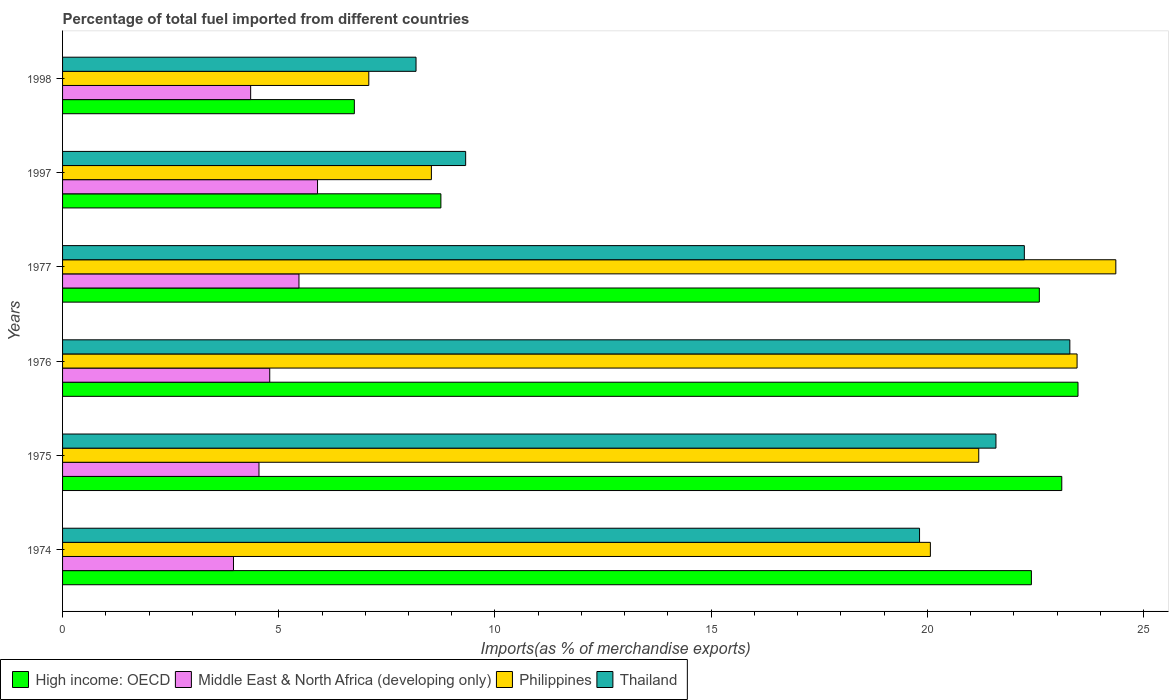How many groups of bars are there?
Give a very brief answer. 6. Are the number of bars on each tick of the Y-axis equal?
Give a very brief answer. Yes. In how many cases, is the number of bars for a given year not equal to the number of legend labels?
Keep it short and to the point. 0. What is the percentage of imports to different countries in Thailand in 1976?
Provide a succinct answer. 23.3. Across all years, what is the maximum percentage of imports to different countries in Middle East & North Africa (developing only)?
Ensure brevity in your answer.  5.9. Across all years, what is the minimum percentage of imports to different countries in High income: OECD?
Your answer should be compact. 6.75. In which year was the percentage of imports to different countries in Thailand maximum?
Make the answer very short. 1976. What is the total percentage of imports to different countries in High income: OECD in the graph?
Provide a succinct answer. 107.09. What is the difference between the percentage of imports to different countries in Middle East & North Africa (developing only) in 1975 and that in 1998?
Keep it short and to the point. 0.19. What is the difference between the percentage of imports to different countries in High income: OECD in 1977 and the percentage of imports to different countries in Philippines in 1974?
Your response must be concise. 2.52. What is the average percentage of imports to different countries in High income: OECD per year?
Provide a succinct answer. 17.85. In the year 1977, what is the difference between the percentage of imports to different countries in Middle East & North Africa (developing only) and percentage of imports to different countries in Thailand?
Provide a succinct answer. -16.78. What is the ratio of the percentage of imports to different countries in Middle East & North Africa (developing only) in 1975 to that in 1998?
Your answer should be compact. 1.04. Is the difference between the percentage of imports to different countries in Middle East & North Africa (developing only) in 1977 and 1997 greater than the difference between the percentage of imports to different countries in Thailand in 1977 and 1997?
Provide a succinct answer. No. What is the difference between the highest and the second highest percentage of imports to different countries in Middle East & North Africa (developing only)?
Offer a very short reply. 0.43. What is the difference between the highest and the lowest percentage of imports to different countries in High income: OECD?
Provide a succinct answer. 16.74. Is the sum of the percentage of imports to different countries in High income: OECD in 1976 and 1977 greater than the maximum percentage of imports to different countries in Thailand across all years?
Keep it short and to the point. Yes. What does the 4th bar from the top in 1975 represents?
Keep it short and to the point. High income: OECD. What does the 4th bar from the bottom in 1998 represents?
Offer a very short reply. Thailand. How many bars are there?
Provide a succinct answer. 24. Are all the bars in the graph horizontal?
Make the answer very short. Yes. How many years are there in the graph?
Your response must be concise. 6. Are the values on the major ticks of X-axis written in scientific E-notation?
Provide a succinct answer. No. Does the graph contain grids?
Offer a terse response. No. How many legend labels are there?
Provide a succinct answer. 4. What is the title of the graph?
Ensure brevity in your answer.  Percentage of total fuel imported from different countries. What is the label or title of the X-axis?
Provide a short and direct response. Imports(as % of merchandise exports). What is the Imports(as % of merchandise exports) of High income: OECD in 1974?
Keep it short and to the point. 22.41. What is the Imports(as % of merchandise exports) in Middle East & North Africa (developing only) in 1974?
Your response must be concise. 3.95. What is the Imports(as % of merchandise exports) in Philippines in 1974?
Offer a very short reply. 20.07. What is the Imports(as % of merchandise exports) of Thailand in 1974?
Your response must be concise. 19.82. What is the Imports(as % of merchandise exports) of High income: OECD in 1975?
Offer a terse response. 23.11. What is the Imports(as % of merchandise exports) in Middle East & North Africa (developing only) in 1975?
Offer a very short reply. 4.54. What is the Imports(as % of merchandise exports) in Philippines in 1975?
Keep it short and to the point. 21.19. What is the Imports(as % of merchandise exports) in Thailand in 1975?
Your answer should be compact. 21.59. What is the Imports(as % of merchandise exports) of High income: OECD in 1976?
Offer a very short reply. 23.48. What is the Imports(as % of merchandise exports) in Middle East & North Africa (developing only) in 1976?
Offer a very short reply. 4.79. What is the Imports(as % of merchandise exports) of Philippines in 1976?
Provide a short and direct response. 23.46. What is the Imports(as % of merchandise exports) of Thailand in 1976?
Ensure brevity in your answer.  23.3. What is the Imports(as % of merchandise exports) of High income: OECD in 1977?
Provide a succinct answer. 22.59. What is the Imports(as % of merchandise exports) of Middle East & North Africa (developing only) in 1977?
Make the answer very short. 5.47. What is the Imports(as % of merchandise exports) in Philippines in 1977?
Your answer should be very brief. 24.36. What is the Imports(as % of merchandise exports) of Thailand in 1977?
Your response must be concise. 22.24. What is the Imports(as % of merchandise exports) in High income: OECD in 1997?
Keep it short and to the point. 8.75. What is the Imports(as % of merchandise exports) of Middle East & North Africa (developing only) in 1997?
Give a very brief answer. 5.9. What is the Imports(as % of merchandise exports) of Philippines in 1997?
Your answer should be compact. 8.53. What is the Imports(as % of merchandise exports) of Thailand in 1997?
Provide a succinct answer. 9.32. What is the Imports(as % of merchandise exports) in High income: OECD in 1998?
Keep it short and to the point. 6.75. What is the Imports(as % of merchandise exports) in Middle East & North Africa (developing only) in 1998?
Make the answer very short. 4.35. What is the Imports(as % of merchandise exports) in Philippines in 1998?
Give a very brief answer. 7.08. What is the Imports(as % of merchandise exports) of Thailand in 1998?
Offer a very short reply. 8.17. Across all years, what is the maximum Imports(as % of merchandise exports) of High income: OECD?
Your answer should be compact. 23.48. Across all years, what is the maximum Imports(as % of merchandise exports) in Middle East & North Africa (developing only)?
Make the answer very short. 5.9. Across all years, what is the maximum Imports(as % of merchandise exports) of Philippines?
Provide a succinct answer. 24.36. Across all years, what is the maximum Imports(as % of merchandise exports) in Thailand?
Ensure brevity in your answer.  23.3. Across all years, what is the minimum Imports(as % of merchandise exports) in High income: OECD?
Give a very brief answer. 6.75. Across all years, what is the minimum Imports(as % of merchandise exports) of Middle East & North Africa (developing only)?
Offer a very short reply. 3.95. Across all years, what is the minimum Imports(as % of merchandise exports) in Philippines?
Your answer should be compact. 7.08. Across all years, what is the minimum Imports(as % of merchandise exports) in Thailand?
Make the answer very short. 8.17. What is the total Imports(as % of merchandise exports) in High income: OECD in the graph?
Your answer should be very brief. 107.09. What is the total Imports(as % of merchandise exports) of Middle East & North Africa (developing only) in the graph?
Keep it short and to the point. 29. What is the total Imports(as % of merchandise exports) in Philippines in the graph?
Offer a terse response. 104.69. What is the total Imports(as % of merchandise exports) of Thailand in the graph?
Provide a short and direct response. 104.44. What is the difference between the Imports(as % of merchandise exports) in High income: OECD in 1974 and that in 1975?
Your answer should be compact. -0.7. What is the difference between the Imports(as % of merchandise exports) in Middle East & North Africa (developing only) in 1974 and that in 1975?
Ensure brevity in your answer.  -0.59. What is the difference between the Imports(as % of merchandise exports) of Philippines in 1974 and that in 1975?
Offer a terse response. -1.12. What is the difference between the Imports(as % of merchandise exports) of Thailand in 1974 and that in 1975?
Make the answer very short. -1.77. What is the difference between the Imports(as % of merchandise exports) of High income: OECD in 1974 and that in 1976?
Your answer should be compact. -1.08. What is the difference between the Imports(as % of merchandise exports) in Middle East & North Africa (developing only) in 1974 and that in 1976?
Your answer should be very brief. -0.84. What is the difference between the Imports(as % of merchandise exports) of Philippines in 1974 and that in 1976?
Give a very brief answer. -3.39. What is the difference between the Imports(as % of merchandise exports) in Thailand in 1974 and that in 1976?
Offer a terse response. -3.48. What is the difference between the Imports(as % of merchandise exports) of High income: OECD in 1974 and that in 1977?
Your response must be concise. -0.18. What is the difference between the Imports(as % of merchandise exports) in Middle East & North Africa (developing only) in 1974 and that in 1977?
Your answer should be compact. -1.51. What is the difference between the Imports(as % of merchandise exports) in Philippines in 1974 and that in 1977?
Offer a very short reply. -4.29. What is the difference between the Imports(as % of merchandise exports) of Thailand in 1974 and that in 1977?
Offer a very short reply. -2.42. What is the difference between the Imports(as % of merchandise exports) of High income: OECD in 1974 and that in 1997?
Your answer should be compact. 13.66. What is the difference between the Imports(as % of merchandise exports) in Middle East & North Africa (developing only) in 1974 and that in 1997?
Your response must be concise. -1.94. What is the difference between the Imports(as % of merchandise exports) in Philippines in 1974 and that in 1997?
Provide a succinct answer. 11.54. What is the difference between the Imports(as % of merchandise exports) in Thailand in 1974 and that in 1997?
Provide a short and direct response. 10.5. What is the difference between the Imports(as % of merchandise exports) in High income: OECD in 1974 and that in 1998?
Keep it short and to the point. 15.66. What is the difference between the Imports(as % of merchandise exports) in Middle East & North Africa (developing only) in 1974 and that in 1998?
Give a very brief answer. -0.4. What is the difference between the Imports(as % of merchandise exports) in Philippines in 1974 and that in 1998?
Give a very brief answer. 12.99. What is the difference between the Imports(as % of merchandise exports) in Thailand in 1974 and that in 1998?
Keep it short and to the point. 11.64. What is the difference between the Imports(as % of merchandise exports) in High income: OECD in 1975 and that in 1976?
Provide a short and direct response. -0.38. What is the difference between the Imports(as % of merchandise exports) in Middle East & North Africa (developing only) in 1975 and that in 1976?
Offer a very short reply. -0.25. What is the difference between the Imports(as % of merchandise exports) in Philippines in 1975 and that in 1976?
Offer a terse response. -2.27. What is the difference between the Imports(as % of merchandise exports) in Thailand in 1975 and that in 1976?
Offer a very short reply. -1.71. What is the difference between the Imports(as % of merchandise exports) of High income: OECD in 1975 and that in 1977?
Your answer should be compact. 0.52. What is the difference between the Imports(as % of merchandise exports) in Middle East & North Africa (developing only) in 1975 and that in 1977?
Provide a succinct answer. -0.92. What is the difference between the Imports(as % of merchandise exports) in Philippines in 1975 and that in 1977?
Your answer should be very brief. -3.17. What is the difference between the Imports(as % of merchandise exports) in Thailand in 1975 and that in 1977?
Offer a terse response. -0.66. What is the difference between the Imports(as % of merchandise exports) in High income: OECD in 1975 and that in 1997?
Make the answer very short. 14.36. What is the difference between the Imports(as % of merchandise exports) of Middle East & North Africa (developing only) in 1975 and that in 1997?
Provide a succinct answer. -1.35. What is the difference between the Imports(as % of merchandise exports) in Philippines in 1975 and that in 1997?
Provide a succinct answer. 12.66. What is the difference between the Imports(as % of merchandise exports) in Thailand in 1975 and that in 1997?
Your answer should be compact. 12.26. What is the difference between the Imports(as % of merchandise exports) in High income: OECD in 1975 and that in 1998?
Make the answer very short. 16.36. What is the difference between the Imports(as % of merchandise exports) in Middle East & North Africa (developing only) in 1975 and that in 1998?
Offer a terse response. 0.19. What is the difference between the Imports(as % of merchandise exports) in Philippines in 1975 and that in 1998?
Offer a terse response. 14.11. What is the difference between the Imports(as % of merchandise exports) in Thailand in 1975 and that in 1998?
Offer a very short reply. 13.41. What is the difference between the Imports(as % of merchandise exports) in High income: OECD in 1976 and that in 1977?
Provide a short and direct response. 0.89. What is the difference between the Imports(as % of merchandise exports) of Middle East & North Africa (developing only) in 1976 and that in 1977?
Offer a terse response. -0.68. What is the difference between the Imports(as % of merchandise exports) of Philippines in 1976 and that in 1977?
Keep it short and to the point. -0.9. What is the difference between the Imports(as % of merchandise exports) of Thailand in 1976 and that in 1977?
Provide a short and direct response. 1.05. What is the difference between the Imports(as % of merchandise exports) of High income: OECD in 1976 and that in 1997?
Make the answer very short. 14.73. What is the difference between the Imports(as % of merchandise exports) in Middle East & North Africa (developing only) in 1976 and that in 1997?
Offer a terse response. -1.11. What is the difference between the Imports(as % of merchandise exports) in Philippines in 1976 and that in 1997?
Your answer should be very brief. 14.93. What is the difference between the Imports(as % of merchandise exports) in Thailand in 1976 and that in 1997?
Your response must be concise. 13.97. What is the difference between the Imports(as % of merchandise exports) of High income: OECD in 1976 and that in 1998?
Make the answer very short. 16.74. What is the difference between the Imports(as % of merchandise exports) of Middle East & North Africa (developing only) in 1976 and that in 1998?
Provide a short and direct response. 0.44. What is the difference between the Imports(as % of merchandise exports) in Philippines in 1976 and that in 1998?
Give a very brief answer. 16.38. What is the difference between the Imports(as % of merchandise exports) of Thailand in 1976 and that in 1998?
Offer a terse response. 15.12. What is the difference between the Imports(as % of merchandise exports) in High income: OECD in 1977 and that in 1997?
Keep it short and to the point. 13.84. What is the difference between the Imports(as % of merchandise exports) in Middle East & North Africa (developing only) in 1977 and that in 1997?
Provide a short and direct response. -0.43. What is the difference between the Imports(as % of merchandise exports) in Philippines in 1977 and that in 1997?
Provide a succinct answer. 15.83. What is the difference between the Imports(as % of merchandise exports) of Thailand in 1977 and that in 1997?
Ensure brevity in your answer.  12.92. What is the difference between the Imports(as % of merchandise exports) of High income: OECD in 1977 and that in 1998?
Give a very brief answer. 15.84. What is the difference between the Imports(as % of merchandise exports) of Middle East & North Africa (developing only) in 1977 and that in 1998?
Your response must be concise. 1.12. What is the difference between the Imports(as % of merchandise exports) in Philippines in 1977 and that in 1998?
Your answer should be very brief. 17.28. What is the difference between the Imports(as % of merchandise exports) in Thailand in 1977 and that in 1998?
Provide a short and direct response. 14.07. What is the difference between the Imports(as % of merchandise exports) of High income: OECD in 1997 and that in 1998?
Provide a succinct answer. 2. What is the difference between the Imports(as % of merchandise exports) in Middle East & North Africa (developing only) in 1997 and that in 1998?
Offer a very short reply. 1.55. What is the difference between the Imports(as % of merchandise exports) in Philippines in 1997 and that in 1998?
Make the answer very short. 1.45. What is the difference between the Imports(as % of merchandise exports) in Thailand in 1997 and that in 1998?
Offer a terse response. 1.15. What is the difference between the Imports(as % of merchandise exports) of High income: OECD in 1974 and the Imports(as % of merchandise exports) of Middle East & North Africa (developing only) in 1975?
Offer a terse response. 17.86. What is the difference between the Imports(as % of merchandise exports) of High income: OECD in 1974 and the Imports(as % of merchandise exports) of Philippines in 1975?
Give a very brief answer. 1.22. What is the difference between the Imports(as % of merchandise exports) of High income: OECD in 1974 and the Imports(as % of merchandise exports) of Thailand in 1975?
Offer a terse response. 0.82. What is the difference between the Imports(as % of merchandise exports) in Middle East & North Africa (developing only) in 1974 and the Imports(as % of merchandise exports) in Philippines in 1975?
Offer a very short reply. -17.24. What is the difference between the Imports(as % of merchandise exports) in Middle East & North Africa (developing only) in 1974 and the Imports(as % of merchandise exports) in Thailand in 1975?
Keep it short and to the point. -17.63. What is the difference between the Imports(as % of merchandise exports) in Philippines in 1974 and the Imports(as % of merchandise exports) in Thailand in 1975?
Provide a succinct answer. -1.52. What is the difference between the Imports(as % of merchandise exports) in High income: OECD in 1974 and the Imports(as % of merchandise exports) in Middle East & North Africa (developing only) in 1976?
Keep it short and to the point. 17.62. What is the difference between the Imports(as % of merchandise exports) in High income: OECD in 1974 and the Imports(as % of merchandise exports) in Philippines in 1976?
Offer a terse response. -1.06. What is the difference between the Imports(as % of merchandise exports) in High income: OECD in 1974 and the Imports(as % of merchandise exports) in Thailand in 1976?
Offer a very short reply. -0.89. What is the difference between the Imports(as % of merchandise exports) of Middle East & North Africa (developing only) in 1974 and the Imports(as % of merchandise exports) of Philippines in 1976?
Provide a short and direct response. -19.51. What is the difference between the Imports(as % of merchandise exports) of Middle East & North Africa (developing only) in 1974 and the Imports(as % of merchandise exports) of Thailand in 1976?
Make the answer very short. -19.34. What is the difference between the Imports(as % of merchandise exports) of Philippines in 1974 and the Imports(as % of merchandise exports) of Thailand in 1976?
Provide a succinct answer. -3.23. What is the difference between the Imports(as % of merchandise exports) in High income: OECD in 1974 and the Imports(as % of merchandise exports) in Middle East & North Africa (developing only) in 1977?
Provide a short and direct response. 16.94. What is the difference between the Imports(as % of merchandise exports) in High income: OECD in 1974 and the Imports(as % of merchandise exports) in Philippines in 1977?
Provide a succinct answer. -1.95. What is the difference between the Imports(as % of merchandise exports) of High income: OECD in 1974 and the Imports(as % of merchandise exports) of Thailand in 1977?
Your answer should be very brief. 0.16. What is the difference between the Imports(as % of merchandise exports) in Middle East & North Africa (developing only) in 1974 and the Imports(as % of merchandise exports) in Philippines in 1977?
Offer a very short reply. -20.41. What is the difference between the Imports(as % of merchandise exports) in Middle East & North Africa (developing only) in 1974 and the Imports(as % of merchandise exports) in Thailand in 1977?
Give a very brief answer. -18.29. What is the difference between the Imports(as % of merchandise exports) in Philippines in 1974 and the Imports(as % of merchandise exports) in Thailand in 1977?
Ensure brevity in your answer.  -2.17. What is the difference between the Imports(as % of merchandise exports) of High income: OECD in 1974 and the Imports(as % of merchandise exports) of Middle East & North Africa (developing only) in 1997?
Ensure brevity in your answer.  16.51. What is the difference between the Imports(as % of merchandise exports) of High income: OECD in 1974 and the Imports(as % of merchandise exports) of Philippines in 1997?
Provide a succinct answer. 13.88. What is the difference between the Imports(as % of merchandise exports) of High income: OECD in 1974 and the Imports(as % of merchandise exports) of Thailand in 1997?
Keep it short and to the point. 13.08. What is the difference between the Imports(as % of merchandise exports) of Middle East & North Africa (developing only) in 1974 and the Imports(as % of merchandise exports) of Philippines in 1997?
Offer a terse response. -4.58. What is the difference between the Imports(as % of merchandise exports) in Middle East & North Africa (developing only) in 1974 and the Imports(as % of merchandise exports) in Thailand in 1997?
Give a very brief answer. -5.37. What is the difference between the Imports(as % of merchandise exports) of Philippines in 1974 and the Imports(as % of merchandise exports) of Thailand in 1997?
Provide a short and direct response. 10.75. What is the difference between the Imports(as % of merchandise exports) of High income: OECD in 1974 and the Imports(as % of merchandise exports) of Middle East & North Africa (developing only) in 1998?
Offer a terse response. 18.06. What is the difference between the Imports(as % of merchandise exports) in High income: OECD in 1974 and the Imports(as % of merchandise exports) in Philippines in 1998?
Offer a very short reply. 15.32. What is the difference between the Imports(as % of merchandise exports) of High income: OECD in 1974 and the Imports(as % of merchandise exports) of Thailand in 1998?
Your answer should be compact. 14.23. What is the difference between the Imports(as % of merchandise exports) in Middle East & North Africa (developing only) in 1974 and the Imports(as % of merchandise exports) in Philippines in 1998?
Ensure brevity in your answer.  -3.13. What is the difference between the Imports(as % of merchandise exports) in Middle East & North Africa (developing only) in 1974 and the Imports(as % of merchandise exports) in Thailand in 1998?
Provide a short and direct response. -4.22. What is the difference between the Imports(as % of merchandise exports) of Philippines in 1974 and the Imports(as % of merchandise exports) of Thailand in 1998?
Ensure brevity in your answer.  11.9. What is the difference between the Imports(as % of merchandise exports) in High income: OECD in 1975 and the Imports(as % of merchandise exports) in Middle East & North Africa (developing only) in 1976?
Give a very brief answer. 18.32. What is the difference between the Imports(as % of merchandise exports) in High income: OECD in 1975 and the Imports(as % of merchandise exports) in Philippines in 1976?
Your answer should be compact. -0.35. What is the difference between the Imports(as % of merchandise exports) in High income: OECD in 1975 and the Imports(as % of merchandise exports) in Thailand in 1976?
Make the answer very short. -0.19. What is the difference between the Imports(as % of merchandise exports) in Middle East & North Africa (developing only) in 1975 and the Imports(as % of merchandise exports) in Philippines in 1976?
Your response must be concise. -18.92. What is the difference between the Imports(as % of merchandise exports) in Middle East & North Africa (developing only) in 1975 and the Imports(as % of merchandise exports) in Thailand in 1976?
Offer a terse response. -18.75. What is the difference between the Imports(as % of merchandise exports) in Philippines in 1975 and the Imports(as % of merchandise exports) in Thailand in 1976?
Your response must be concise. -2.11. What is the difference between the Imports(as % of merchandise exports) of High income: OECD in 1975 and the Imports(as % of merchandise exports) of Middle East & North Africa (developing only) in 1977?
Keep it short and to the point. 17.64. What is the difference between the Imports(as % of merchandise exports) of High income: OECD in 1975 and the Imports(as % of merchandise exports) of Philippines in 1977?
Keep it short and to the point. -1.25. What is the difference between the Imports(as % of merchandise exports) in High income: OECD in 1975 and the Imports(as % of merchandise exports) in Thailand in 1977?
Provide a succinct answer. 0.87. What is the difference between the Imports(as % of merchandise exports) of Middle East & North Africa (developing only) in 1975 and the Imports(as % of merchandise exports) of Philippines in 1977?
Provide a succinct answer. -19.82. What is the difference between the Imports(as % of merchandise exports) of Middle East & North Africa (developing only) in 1975 and the Imports(as % of merchandise exports) of Thailand in 1977?
Your answer should be compact. -17.7. What is the difference between the Imports(as % of merchandise exports) in Philippines in 1975 and the Imports(as % of merchandise exports) in Thailand in 1977?
Offer a terse response. -1.05. What is the difference between the Imports(as % of merchandise exports) in High income: OECD in 1975 and the Imports(as % of merchandise exports) in Middle East & North Africa (developing only) in 1997?
Give a very brief answer. 17.21. What is the difference between the Imports(as % of merchandise exports) in High income: OECD in 1975 and the Imports(as % of merchandise exports) in Philippines in 1997?
Give a very brief answer. 14.58. What is the difference between the Imports(as % of merchandise exports) in High income: OECD in 1975 and the Imports(as % of merchandise exports) in Thailand in 1997?
Offer a terse response. 13.79. What is the difference between the Imports(as % of merchandise exports) in Middle East & North Africa (developing only) in 1975 and the Imports(as % of merchandise exports) in Philippines in 1997?
Provide a short and direct response. -3.99. What is the difference between the Imports(as % of merchandise exports) in Middle East & North Africa (developing only) in 1975 and the Imports(as % of merchandise exports) in Thailand in 1997?
Provide a succinct answer. -4.78. What is the difference between the Imports(as % of merchandise exports) of Philippines in 1975 and the Imports(as % of merchandise exports) of Thailand in 1997?
Make the answer very short. 11.87. What is the difference between the Imports(as % of merchandise exports) in High income: OECD in 1975 and the Imports(as % of merchandise exports) in Middle East & North Africa (developing only) in 1998?
Provide a short and direct response. 18.76. What is the difference between the Imports(as % of merchandise exports) of High income: OECD in 1975 and the Imports(as % of merchandise exports) of Philippines in 1998?
Your response must be concise. 16.03. What is the difference between the Imports(as % of merchandise exports) of High income: OECD in 1975 and the Imports(as % of merchandise exports) of Thailand in 1998?
Your answer should be very brief. 14.93. What is the difference between the Imports(as % of merchandise exports) of Middle East & North Africa (developing only) in 1975 and the Imports(as % of merchandise exports) of Philippines in 1998?
Your answer should be very brief. -2.54. What is the difference between the Imports(as % of merchandise exports) of Middle East & North Africa (developing only) in 1975 and the Imports(as % of merchandise exports) of Thailand in 1998?
Ensure brevity in your answer.  -3.63. What is the difference between the Imports(as % of merchandise exports) in Philippines in 1975 and the Imports(as % of merchandise exports) in Thailand in 1998?
Provide a short and direct response. 13.01. What is the difference between the Imports(as % of merchandise exports) of High income: OECD in 1976 and the Imports(as % of merchandise exports) of Middle East & North Africa (developing only) in 1977?
Your answer should be very brief. 18.02. What is the difference between the Imports(as % of merchandise exports) of High income: OECD in 1976 and the Imports(as % of merchandise exports) of Philippines in 1977?
Give a very brief answer. -0.87. What is the difference between the Imports(as % of merchandise exports) of High income: OECD in 1976 and the Imports(as % of merchandise exports) of Thailand in 1977?
Your answer should be very brief. 1.24. What is the difference between the Imports(as % of merchandise exports) of Middle East & North Africa (developing only) in 1976 and the Imports(as % of merchandise exports) of Philippines in 1977?
Provide a short and direct response. -19.57. What is the difference between the Imports(as % of merchandise exports) in Middle East & North Africa (developing only) in 1976 and the Imports(as % of merchandise exports) in Thailand in 1977?
Ensure brevity in your answer.  -17.45. What is the difference between the Imports(as % of merchandise exports) of Philippines in 1976 and the Imports(as % of merchandise exports) of Thailand in 1977?
Keep it short and to the point. 1.22. What is the difference between the Imports(as % of merchandise exports) in High income: OECD in 1976 and the Imports(as % of merchandise exports) in Middle East & North Africa (developing only) in 1997?
Your answer should be compact. 17.59. What is the difference between the Imports(as % of merchandise exports) of High income: OECD in 1976 and the Imports(as % of merchandise exports) of Philippines in 1997?
Provide a short and direct response. 14.95. What is the difference between the Imports(as % of merchandise exports) of High income: OECD in 1976 and the Imports(as % of merchandise exports) of Thailand in 1997?
Ensure brevity in your answer.  14.16. What is the difference between the Imports(as % of merchandise exports) of Middle East & North Africa (developing only) in 1976 and the Imports(as % of merchandise exports) of Philippines in 1997?
Provide a short and direct response. -3.74. What is the difference between the Imports(as % of merchandise exports) in Middle East & North Africa (developing only) in 1976 and the Imports(as % of merchandise exports) in Thailand in 1997?
Ensure brevity in your answer.  -4.53. What is the difference between the Imports(as % of merchandise exports) of Philippines in 1976 and the Imports(as % of merchandise exports) of Thailand in 1997?
Provide a short and direct response. 14.14. What is the difference between the Imports(as % of merchandise exports) in High income: OECD in 1976 and the Imports(as % of merchandise exports) in Middle East & North Africa (developing only) in 1998?
Ensure brevity in your answer.  19.13. What is the difference between the Imports(as % of merchandise exports) of High income: OECD in 1976 and the Imports(as % of merchandise exports) of Philippines in 1998?
Ensure brevity in your answer.  16.4. What is the difference between the Imports(as % of merchandise exports) of High income: OECD in 1976 and the Imports(as % of merchandise exports) of Thailand in 1998?
Offer a very short reply. 15.31. What is the difference between the Imports(as % of merchandise exports) in Middle East & North Africa (developing only) in 1976 and the Imports(as % of merchandise exports) in Philippines in 1998?
Offer a terse response. -2.29. What is the difference between the Imports(as % of merchandise exports) in Middle East & North Africa (developing only) in 1976 and the Imports(as % of merchandise exports) in Thailand in 1998?
Give a very brief answer. -3.38. What is the difference between the Imports(as % of merchandise exports) of Philippines in 1976 and the Imports(as % of merchandise exports) of Thailand in 1998?
Provide a succinct answer. 15.29. What is the difference between the Imports(as % of merchandise exports) of High income: OECD in 1977 and the Imports(as % of merchandise exports) of Middle East & North Africa (developing only) in 1997?
Offer a terse response. 16.69. What is the difference between the Imports(as % of merchandise exports) in High income: OECD in 1977 and the Imports(as % of merchandise exports) in Philippines in 1997?
Ensure brevity in your answer.  14.06. What is the difference between the Imports(as % of merchandise exports) of High income: OECD in 1977 and the Imports(as % of merchandise exports) of Thailand in 1997?
Provide a succinct answer. 13.27. What is the difference between the Imports(as % of merchandise exports) of Middle East & North Africa (developing only) in 1977 and the Imports(as % of merchandise exports) of Philippines in 1997?
Make the answer very short. -3.06. What is the difference between the Imports(as % of merchandise exports) in Middle East & North Africa (developing only) in 1977 and the Imports(as % of merchandise exports) in Thailand in 1997?
Offer a terse response. -3.85. What is the difference between the Imports(as % of merchandise exports) of Philippines in 1977 and the Imports(as % of merchandise exports) of Thailand in 1997?
Keep it short and to the point. 15.04. What is the difference between the Imports(as % of merchandise exports) in High income: OECD in 1977 and the Imports(as % of merchandise exports) in Middle East & North Africa (developing only) in 1998?
Offer a very short reply. 18.24. What is the difference between the Imports(as % of merchandise exports) in High income: OECD in 1977 and the Imports(as % of merchandise exports) in Philippines in 1998?
Your response must be concise. 15.51. What is the difference between the Imports(as % of merchandise exports) in High income: OECD in 1977 and the Imports(as % of merchandise exports) in Thailand in 1998?
Make the answer very short. 14.42. What is the difference between the Imports(as % of merchandise exports) in Middle East & North Africa (developing only) in 1977 and the Imports(as % of merchandise exports) in Philippines in 1998?
Offer a very short reply. -1.61. What is the difference between the Imports(as % of merchandise exports) of Middle East & North Africa (developing only) in 1977 and the Imports(as % of merchandise exports) of Thailand in 1998?
Make the answer very short. -2.71. What is the difference between the Imports(as % of merchandise exports) of Philippines in 1977 and the Imports(as % of merchandise exports) of Thailand in 1998?
Ensure brevity in your answer.  16.18. What is the difference between the Imports(as % of merchandise exports) in High income: OECD in 1997 and the Imports(as % of merchandise exports) in Middle East & North Africa (developing only) in 1998?
Provide a succinct answer. 4.4. What is the difference between the Imports(as % of merchandise exports) in High income: OECD in 1997 and the Imports(as % of merchandise exports) in Philippines in 1998?
Your answer should be very brief. 1.67. What is the difference between the Imports(as % of merchandise exports) of High income: OECD in 1997 and the Imports(as % of merchandise exports) of Thailand in 1998?
Keep it short and to the point. 0.57. What is the difference between the Imports(as % of merchandise exports) in Middle East & North Africa (developing only) in 1997 and the Imports(as % of merchandise exports) in Philippines in 1998?
Keep it short and to the point. -1.19. What is the difference between the Imports(as % of merchandise exports) in Middle East & North Africa (developing only) in 1997 and the Imports(as % of merchandise exports) in Thailand in 1998?
Provide a short and direct response. -2.28. What is the difference between the Imports(as % of merchandise exports) in Philippines in 1997 and the Imports(as % of merchandise exports) in Thailand in 1998?
Keep it short and to the point. 0.36. What is the average Imports(as % of merchandise exports) of High income: OECD per year?
Ensure brevity in your answer.  17.85. What is the average Imports(as % of merchandise exports) of Middle East & North Africa (developing only) per year?
Provide a short and direct response. 4.83. What is the average Imports(as % of merchandise exports) in Philippines per year?
Offer a terse response. 17.45. What is the average Imports(as % of merchandise exports) of Thailand per year?
Your answer should be very brief. 17.41. In the year 1974, what is the difference between the Imports(as % of merchandise exports) of High income: OECD and Imports(as % of merchandise exports) of Middle East & North Africa (developing only)?
Offer a very short reply. 18.45. In the year 1974, what is the difference between the Imports(as % of merchandise exports) in High income: OECD and Imports(as % of merchandise exports) in Philippines?
Your answer should be compact. 2.34. In the year 1974, what is the difference between the Imports(as % of merchandise exports) in High income: OECD and Imports(as % of merchandise exports) in Thailand?
Make the answer very short. 2.59. In the year 1974, what is the difference between the Imports(as % of merchandise exports) in Middle East & North Africa (developing only) and Imports(as % of merchandise exports) in Philippines?
Ensure brevity in your answer.  -16.12. In the year 1974, what is the difference between the Imports(as % of merchandise exports) of Middle East & North Africa (developing only) and Imports(as % of merchandise exports) of Thailand?
Provide a succinct answer. -15.87. In the year 1974, what is the difference between the Imports(as % of merchandise exports) in Philippines and Imports(as % of merchandise exports) in Thailand?
Give a very brief answer. 0.25. In the year 1975, what is the difference between the Imports(as % of merchandise exports) in High income: OECD and Imports(as % of merchandise exports) in Middle East & North Africa (developing only)?
Your answer should be very brief. 18.57. In the year 1975, what is the difference between the Imports(as % of merchandise exports) in High income: OECD and Imports(as % of merchandise exports) in Philippines?
Your answer should be compact. 1.92. In the year 1975, what is the difference between the Imports(as % of merchandise exports) of High income: OECD and Imports(as % of merchandise exports) of Thailand?
Your response must be concise. 1.52. In the year 1975, what is the difference between the Imports(as % of merchandise exports) in Middle East & North Africa (developing only) and Imports(as % of merchandise exports) in Philippines?
Ensure brevity in your answer.  -16.65. In the year 1975, what is the difference between the Imports(as % of merchandise exports) of Middle East & North Africa (developing only) and Imports(as % of merchandise exports) of Thailand?
Your answer should be very brief. -17.04. In the year 1975, what is the difference between the Imports(as % of merchandise exports) in Philippines and Imports(as % of merchandise exports) in Thailand?
Provide a succinct answer. -0.4. In the year 1976, what is the difference between the Imports(as % of merchandise exports) of High income: OECD and Imports(as % of merchandise exports) of Middle East & North Africa (developing only)?
Provide a short and direct response. 18.69. In the year 1976, what is the difference between the Imports(as % of merchandise exports) in High income: OECD and Imports(as % of merchandise exports) in Philippines?
Offer a very short reply. 0.02. In the year 1976, what is the difference between the Imports(as % of merchandise exports) in High income: OECD and Imports(as % of merchandise exports) in Thailand?
Give a very brief answer. 0.19. In the year 1976, what is the difference between the Imports(as % of merchandise exports) of Middle East & North Africa (developing only) and Imports(as % of merchandise exports) of Philippines?
Give a very brief answer. -18.67. In the year 1976, what is the difference between the Imports(as % of merchandise exports) of Middle East & North Africa (developing only) and Imports(as % of merchandise exports) of Thailand?
Provide a short and direct response. -18.5. In the year 1976, what is the difference between the Imports(as % of merchandise exports) of Philippines and Imports(as % of merchandise exports) of Thailand?
Your response must be concise. 0.17. In the year 1977, what is the difference between the Imports(as % of merchandise exports) in High income: OECD and Imports(as % of merchandise exports) in Middle East & North Africa (developing only)?
Provide a succinct answer. 17.12. In the year 1977, what is the difference between the Imports(as % of merchandise exports) in High income: OECD and Imports(as % of merchandise exports) in Philippines?
Your answer should be compact. -1.77. In the year 1977, what is the difference between the Imports(as % of merchandise exports) of High income: OECD and Imports(as % of merchandise exports) of Thailand?
Ensure brevity in your answer.  0.35. In the year 1977, what is the difference between the Imports(as % of merchandise exports) of Middle East & North Africa (developing only) and Imports(as % of merchandise exports) of Philippines?
Your answer should be very brief. -18.89. In the year 1977, what is the difference between the Imports(as % of merchandise exports) in Middle East & North Africa (developing only) and Imports(as % of merchandise exports) in Thailand?
Ensure brevity in your answer.  -16.78. In the year 1977, what is the difference between the Imports(as % of merchandise exports) of Philippines and Imports(as % of merchandise exports) of Thailand?
Offer a terse response. 2.12. In the year 1997, what is the difference between the Imports(as % of merchandise exports) in High income: OECD and Imports(as % of merchandise exports) in Middle East & North Africa (developing only)?
Make the answer very short. 2.85. In the year 1997, what is the difference between the Imports(as % of merchandise exports) of High income: OECD and Imports(as % of merchandise exports) of Philippines?
Offer a terse response. 0.22. In the year 1997, what is the difference between the Imports(as % of merchandise exports) of High income: OECD and Imports(as % of merchandise exports) of Thailand?
Provide a short and direct response. -0.57. In the year 1997, what is the difference between the Imports(as % of merchandise exports) of Middle East & North Africa (developing only) and Imports(as % of merchandise exports) of Philippines?
Provide a succinct answer. -2.63. In the year 1997, what is the difference between the Imports(as % of merchandise exports) of Middle East & North Africa (developing only) and Imports(as % of merchandise exports) of Thailand?
Your answer should be very brief. -3.43. In the year 1997, what is the difference between the Imports(as % of merchandise exports) in Philippines and Imports(as % of merchandise exports) in Thailand?
Offer a very short reply. -0.79. In the year 1998, what is the difference between the Imports(as % of merchandise exports) of High income: OECD and Imports(as % of merchandise exports) of Middle East & North Africa (developing only)?
Provide a succinct answer. 2.4. In the year 1998, what is the difference between the Imports(as % of merchandise exports) in High income: OECD and Imports(as % of merchandise exports) in Philippines?
Offer a terse response. -0.33. In the year 1998, what is the difference between the Imports(as % of merchandise exports) in High income: OECD and Imports(as % of merchandise exports) in Thailand?
Provide a short and direct response. -1.43. In the year 1998, what is the difference between the Imports(as % of merchandise exports) of Middle East & North Africa (developing only) and Imports(as % of merchandise exports) of Philippines?
Ensure brevity in your answer.  -2.73. In the year 1998, what is the difference between the Imports(as % of merchandise exports) in Middle East & North Africa (developing only) and Imports(as % of merchandise exports) in Thailand?
Your response must be concise. -3.82. In the year 1998, what is the difference between the Imports(as % of merchandise exports) in Philippines and Imports(as % of merchandise exports) in Thailand?
Give a very brief answer. -1.09. What is the ratio of the Imports(as % of merchandise exports) in High income: OECD in 1974 to that in 1975?
Provide a succinct answer. 0.97. What is the ratio of the Imports(as % of merchandise exports) of Middle East & North Africa (developing only) in 1974 to that in 1975?
Your answer should be very brief. 0.87. What is the ratio of the Imports(as % of merchandise exports) of Philippines in 1974 to that in 1975?
Offer a very short reply. 0.95. What is the ratio of the Imports(as % of merchandise exports) of Thailand in 1974 to that in 1975?
Ensure brevity in your answer.  0.92. What is the ratio of the Imports(as % of merchandise exports) in High income: OECD in 1974 to that in 1976?
Provide a succinct answer. 0.95. What is the ratio of the Imports(as % of merchandise exports) in Middle East & North Africa (developing only) in 1974 to that in 1976?
Provide a succinct answer. 0.82. What is the ratio of the Imports(as % of merchandise exports) in Philippines in 1974 to that in 1976?
Your answer should be very brief. 0.86. What is the ratio of the Imports(as % of merchandise exports) in Thailand in 1974 to that in 1976?
Ensure brevity in your answer.  0.85. What is the ratio of the Imports(as % of merchandise exports) of High income: OECD in 1974 to that in 1977?
Your response must be concise. 0.99. What is the ratio of the Imports(as % of merchandise exports) in Middle East & North Africa (developing only) in 1974 to that in 1977?
Give a very brief answer. 0.72. What is the ratio of the Imports(as % of merchandise exports) in Philippines in 1974 to that in 1977?
Give a very brief answer. 0.82. What is the ratio of the Imports(as % of merchandise exports) of Thailand in 1974 to that in 1977?
Keep it short and to the point. 0.89. What is the ratio of the Imports(as % of merchandise exports) in High income: OECD in 1974 to that in 1997?
Provide a short and direct response. 2.56. What is the ratio of the Imports(as % of merchandise exports) in Middle East & North Africa (developing only) in 1974 to that in 1997?
Provide a short and direct response. 0.67. What is the ratio of the Imports(as % of merchandise exports) of Philippines in 1974 to that in 1997?
Offer a terse response. 2.35. What is the ratio of the Imports(as % of merchandise exports) in Thailand in 1974 to that in 1997?
Provide a short and direct response. 2.13. What is the ratio of the Imports(as % of merchandise exports) of High income: OECD in 1974 to that in 1998?
Make the answer very short. 3.32. What is the ratio of the Imports(as % of merchandise exports) of Middle East & North Africa (developing only) in 1974 to that in 1998?
Your response must be concise. 0.91. What is the ratio of the Imports(as % of merchandise exports) of Philippines in 1974 to that in 1998?
Make the answer very short. 2.83. What is the ratio of the Imports(as % of merchandise exports) in Thailand in 1974 to that in 1998?
Provide a succinct answer. 2.42. What is the ratio of the Imports(as % of merchandise exports) of Middle East & North Africa (developing only) in 1975 to that in 1976?
Give a very brief answer. 0.95. What is the ratio of the Imports(as % of merchandise exports) of Philippines in 1975 to that in 1976?
Your answer should be very brief. 0.9. What is the ratio of the Imports(as % of merchandise exports) in Thailand in 1975 to that in 1976?
Provide a short and direct response. 0.93. What is the ratio of the Imports(as % of merchandise exports) in Middle East & North Africa (developing only) in 1975 to that in 1977?
Your answer should be very brief. 0.83. What is the ratio of the Imports(as % of merchandise exports) in Philippines in 1975 to that in 1977?
Ensure brevity in your answer.  0.87. What is the ratio of the Imports(as % of merchandise exports) of Thailand in 1975 to that in 1977?
Provide a succinct answer. 0.97. What is the ratio of the Imports(as % of merchandise exports) in High income: OECD in 1975 to that in 1997?
Make the answer very short. 2.64. What is the ratio of the Imports(as % of merchandise exports) of Middle East & North Africa (developing only) in 1975 to that in 1997?
Offer a terse response. 0.77. What is the ratio of the Imports(as % of merchandise exports) in Philippines in 1975 to that in 1997?
Ensure brevity in your answer.  2.48. What is the ratio of the Imports(as % of merchandise exports) of Thailand in 1975 to that in 1997?
Provide a succinct answer. 2.32. What is the ratio of the Imports(as % of merchandise exports) of High income: OECD in 1975 to that in 1998?
Provide a succinct answer. 3.42. What is the ratio of the Imports(as % of merchandise exports) in Middle East & North Africa (developing only) in 1975 to that in 1998?
Give a very brief answer. 1.04. What is the ratio of the Imports(as % of merchandise exports) of Philippines in 1975 to that in 1998?
Keep it short and to the point. 2.99. What is the ratio of the Imports(as % of merchandise exports) of Thailand in 1975 to that in 1998?
Ensure brevity in your answer.  2.64. What is the ratio of the Imports(as % of merchandise exports) of High income: OECD in 1976 to that in 1977?
Your answer should be very brief. 1.04. What is the ratio of the Imports(as % of merchandise exports) of Middle East & North Africa (developing only) in 1976 to that in 1977?
Give a very brief answer. 0.88. What is the ratio of the Imports(as % of merchandise exports) of Philippines in 1976 to that in 1977?
Keep it short and to the point. 0.96. What is the ratio of the Imports(as % of merchandise exports) of Thailand in 1976 to that in 1977?
Give a very brief answer. 1.05. What is the ratio of the Imports(as % of merchandise exports) in High income: OECD in 1976 to that in 1997?
Offer a very short reply. 2.68. What is the ratio of the Imports(as % of merchandise exports) in Middle East & North Africa (developing only) in 1976 to that in 1997?
Provide a short and direct response. 0.81. What is the ratio of the Imports(as % of merchandise exports) in Philippines in 1976 to that in 1997?
Make the answer very short. 2.75. What is the ratio of the Imports(as % of merchandise exports) of Thailand in 1976 to that in 1997?
Keep it short and to the point. 2.5. What is the ratio of the Imports(as % of merchandise exports) of High income: OECD in 1976 to that in 1998?
Provide a succinct answer. 3.48. What is the ratio of the Imports(as % of merchandise exports) in Middle East & North Africa (developing only) in 1976 to that in 1998?
Make the answer very short. 1.1. What is the ratio of the Imports(as % of merchandise exports) in Philippines in 1976 to that in 1998?
Make the answer very short. 3.31. What is the ratio of the Imports(as % of merchandise exports) in Thailand in 1976 to that in 1998?
Your answer should be compact. 2.85. What is the ratio of the Imports(as % of merchandise exports) in High income: OECD in 1977 to that in 1997?
Offer a very short reply. 2.58. What is the ratio of the Imports(as % of merchandise exports) in Middle East & North Africa (developing only) in 1977 to that in 1997?
Keep it short and to the point. 0.93. What is the ratio of the Imports(as % of merchandise exports) of Philippines in 1977 to that in 1997?
Offer a very short reply. 2.86. What is the ratio of the Imports(as % of merchandise exports) of Thailand in 1977 to that in 1997?
Keep it short and to the point. 2.39. What is the ratio of the Imports(as % of merchandise exports) of High income: OECD in 1977 to that in 1998?
Offer a very short reply. 3.35. What is the ratio of the Imports(as % of merchandise exports) of Middle East & North Africa (developing only) in 1977 to that in 1998?
Provide a succinct answer. 1.26. What is the ratio of the Imports(as % of merchandise exports) of Philippines in 1977 to that in 1998?
Make the answer very short. 3.44. What is the ratio of the Imports(as % of merchandise exports) in Thailand in 1977 to that in 1998?
Provide a short and direct response. 2.72. What is the ratio of the Imports(as % of merchandise exports) in High income: OECD in 1997 to that in 1998?
Provide a short and direct response. 1.3. What is the ratio of the Imports(as % of merchandise exports) in Middle East & North Africa (developing only) in 1997 to that in 1998?
Offer a terse response. 1.36. What is the ratio of the Imports(as % of merchandise exports) in Philippines in 1997 to that in 1998?
Make the answer very short. 1.2. What is the ratio of the Imports(as % of merchandise exports) in Thailand in 1997 to that in 1998?
Make the answer very short. 1.14. What is the difference between the highest and the second highest Imports(as % of merchandise exports) of Middle East & North Africa (developing only)?
Offer a very short reply. 0.43. What is the difference between the highest and the second highest Imports(as % of merchandise exports) of Philippines?
Provide a succinct answer. 0.9. What is the difference between the highest and the second highest Imports(as % of merchandise exports) in Thailand?
Keep it short and to the point. 1.05. What is the difference between the highest and the lowest Imports(as % of merchandise exports) of High income: OECD?
Offer a very short reply. 16.74. What is the difference between the highest and the lowest Imports(as % of merchandise exports) in Middle East & North Africa (developing only)?
Your answer should be very brief. 1.94. What is the difference between the highest and the lowest Imports(as % of merchandise exports) of Philippines?
Offer a very short reply. 17.28. What is the difference between the highest and the lowest Imports(as % of merchandise exports) of Thailand?
Give a very brief answer. 15.12. 